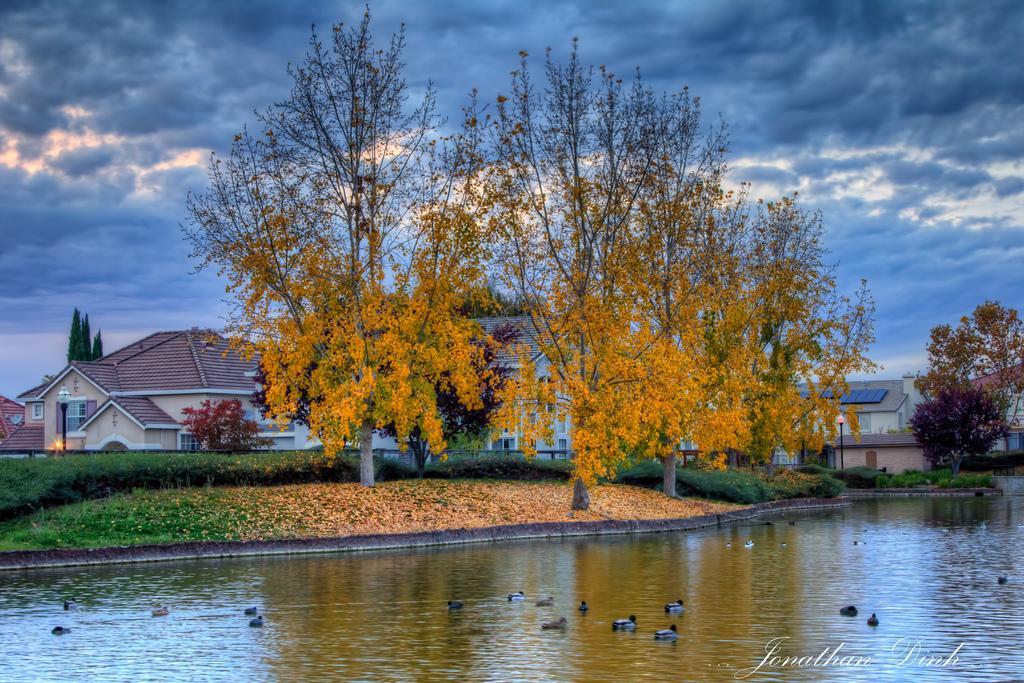Describe this image in one or two sentences. In the foreground there is a water body, in the water we can see ducks. In the middle of the picture there are trees, buildings, plants, dry leaves, pole and various objects. At the top it is sky. The sky is cloudy. 